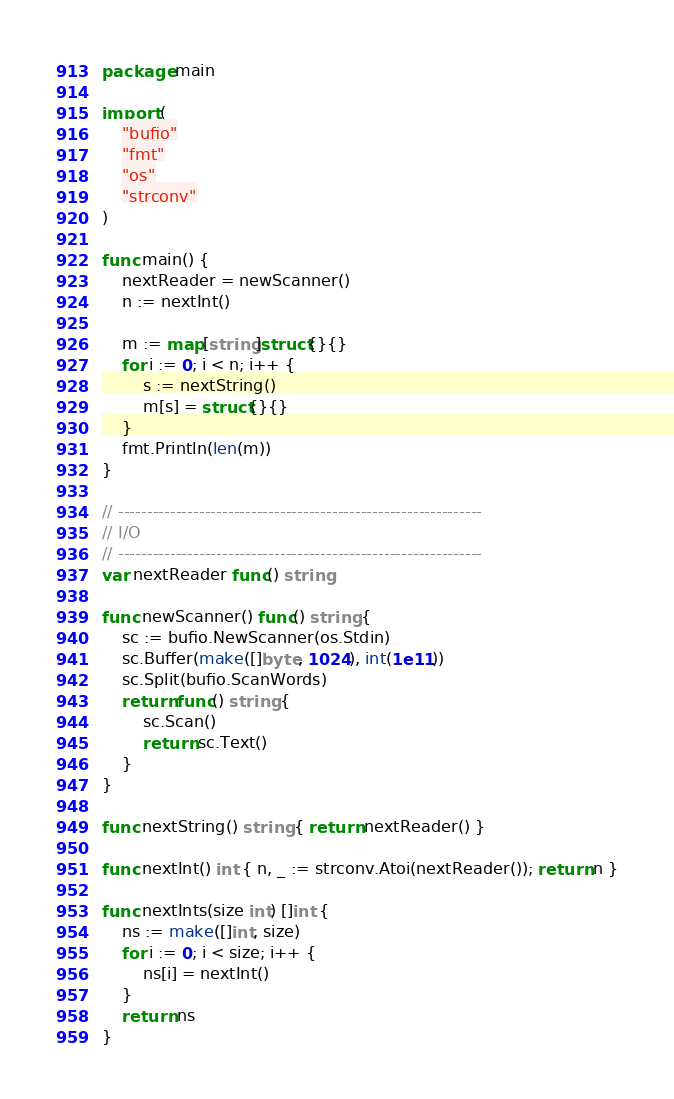Convert code to text. <code><loc_0><loc_0><loc_500><loc_500><_Go_>package main

import (
	"bufio"
	"fmt"
	"os"
	"strconv"
)

func main() {
	nextReader = newScanner()
	n := nextInt()

	m := map[string]struct{}{}
	for i := 0; i < n; i++ {
		s := nextString()
		m[s] = struct{}{}
	}
	fmt.Println(len(m))
}

// ---------------------------------------------------------------
// I/O
// ---------------------------------------------------------------
var nextReader func() string

func newScanner() func() string {
	sc := bufio.NewScanner(os.Stdin)
	sc.Buffer(make([]byte, 1024), int(1e11))
	sc.Split(bufio.ScanWords)
	return func() string {
		sc.Scan()
		return sc.Text()
	}
}

func nextString() string { return nextReader() }

func nextInt() int { n, _ := strconv.Atoi(nextReader()); return n }

func nextInts(size int) []int {
	ns := make([]int, size)
	for i := 0; i < size; i++ {
		ns[i] = nextInt()
	}
	return ns
}
</code> 